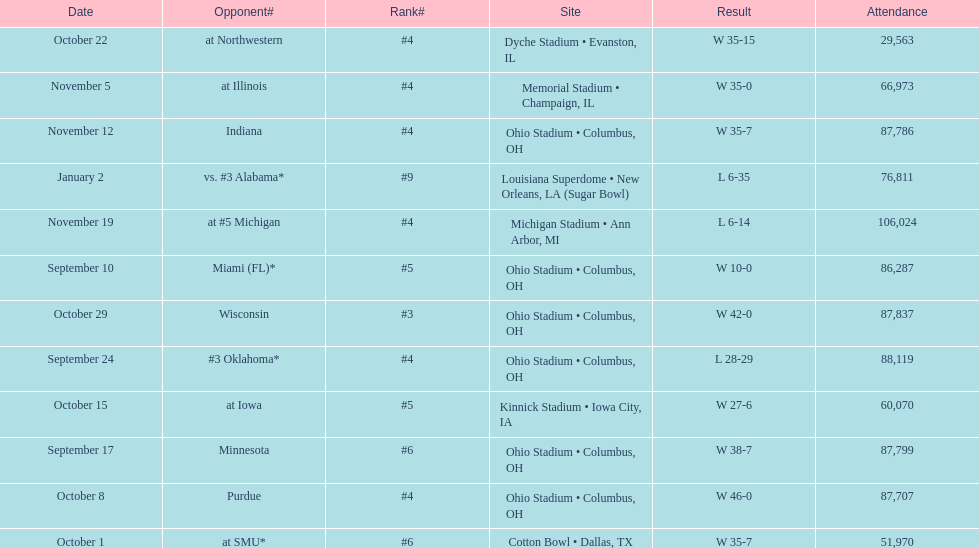In how many games were than more than 80,000 people attending 7. 